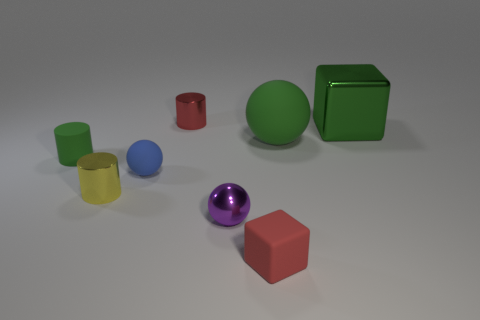Add 1 tiny red matte blocks. How many objects exist? 9 Subtract all green matte spheres. How many spheres are left? 2 Subtract all red blocks. How many blocks are left? 1 Subtract 1 purple spheres. How many objects are left? 7 Subtract all balls. How many objects are left? 5 Subtract 1 balls. How many balls are left? 2 Subtract all brown blocks. Subtract all red spheres. How many blocks are left? 2 Subtract all brown balls. How many red blocks are left? 1 Subtract all large gray things. Subtract all small balls. How many objects are left? 6 Add 3 tiny red shiny cylinders. How many tiny red shiny cylinders are left? 4 